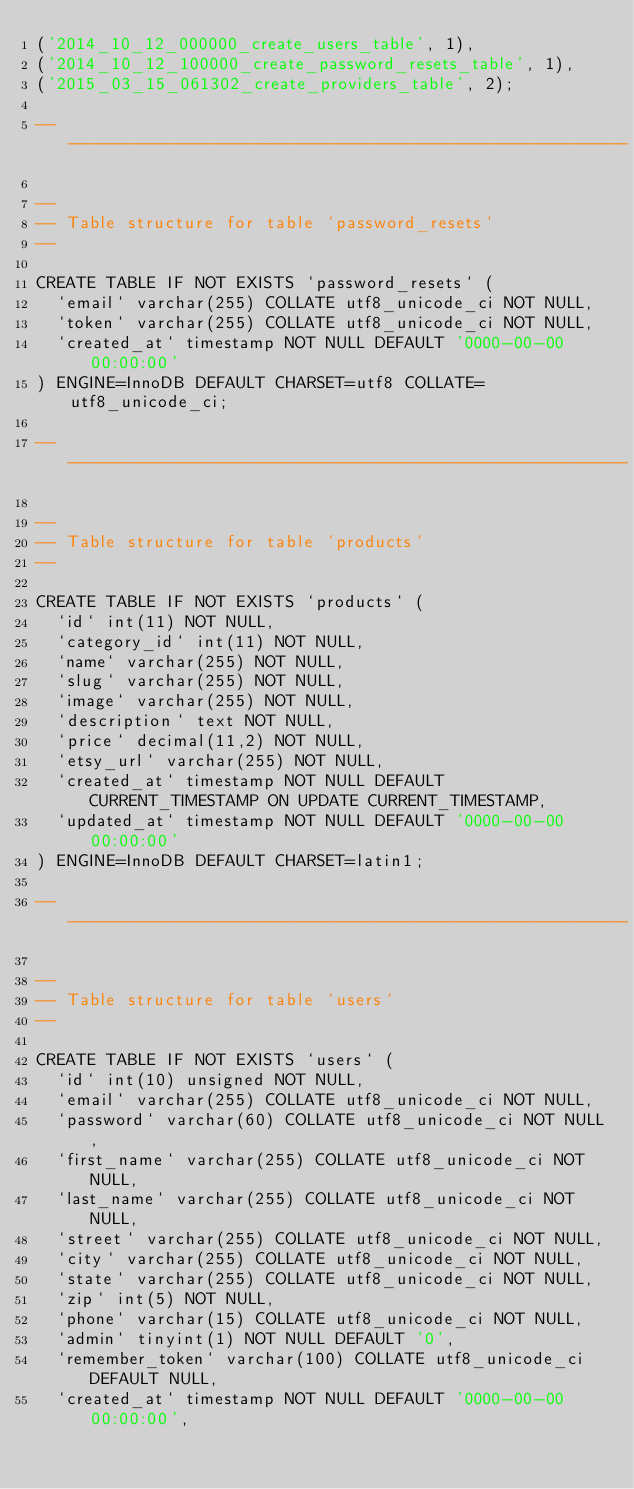<code> <loc_0><loc_0><loc_500><loc_500><_SQL_>('2014_10_12_000000_create_users_table', 1),
('2014_10_12_100000_create_password_resets_table', 1),
('2015_03_15_061302_create_providers_table', 2);

-- --------------------------------------------------------

--
-- Table structure for table `password_resets`
--

CREATE TABLE IF NOT EXISTS `password_resets` (
  `email` varchar(255) COLLATE utf8_unicode_ci NOT NULL,
  `token` varchar(255) COLLATE utf8_unicode_ci NOT NULL,
  `created_at` timestamp NOT NULL DEFAULT '0000-00-00 00:00:00'
) ENGINE=InnoDB DEFAULT CHARSET=utf8 COLLATE=utf8_unicode_ci;

-- --------------------------------------------------------

--
-- Table structure for table `products`
--

CREATE TABLE IF NOT EXISTS `products` (
  `id` int(11) NOT NULL,
  `category_id` int(11) NOT NULL,
  `name` varchar(255) NOT NULL,
  `slug` varchar(255) NOT NULL,
  `image` varchar(255) NOT NULL,
  `description` text NOT NULL,
  `price` decimal(11,2) NOT NULL,
  `etsy_url` varchar(255) NOT NULL,
  `created_at` timestamp NOT NULL DEFAULT CURRENT_TIMESTAMP ON UPDATE CURRENT_TIMESTAMP,
  `updated_at` timestamp NOT NULL DEFAULT '0000-00-00 00:00:00'
) ENGINE=InnoDB DEFAULT CHARSET=latin1;

-- --------------------------------------------------------

--
-- Table structure for table `users`
--

CREATE TABLE IF NOT EXISTS `users` (
  `id` int(10) unsigned NOT NULL,
  `email` varchar(255) COLLATE utf8_unicode_ci NOT NULL,
  `password` varchar(60) COLLATE utf8_unicode_ci NOT NULL,
  `first_name` varchar(255) COLLATE utf8_unicode_ci NOT NULL,
  `last_name` varchar(255) COLLATE utf8_unicode_ci NOT NULL,
  `street` varchar(255) COLLATE utf8_unicode_ci NOT NULL,
  `city` varchar(255) COLLATE utf8_unicode_ci NOT NULL,
  `state` varchar(255) COLLATE utf8_unicode_ci NOT NULL,
  `zip` int(5) NOT NULL,
  `phone` varchar(15) COLLATE utf8_unicode_ci NOT NULL,
  `admin` tinyint(1) NOT NULL DEFAULT '0',
  `remember_token` varchar(100) COLLATE utf8_unicode_ci DEFAULT NULL,
  `created_at` timestamp NOT NULL DEFAULT '0000-00-00 00:00:00',</code> 